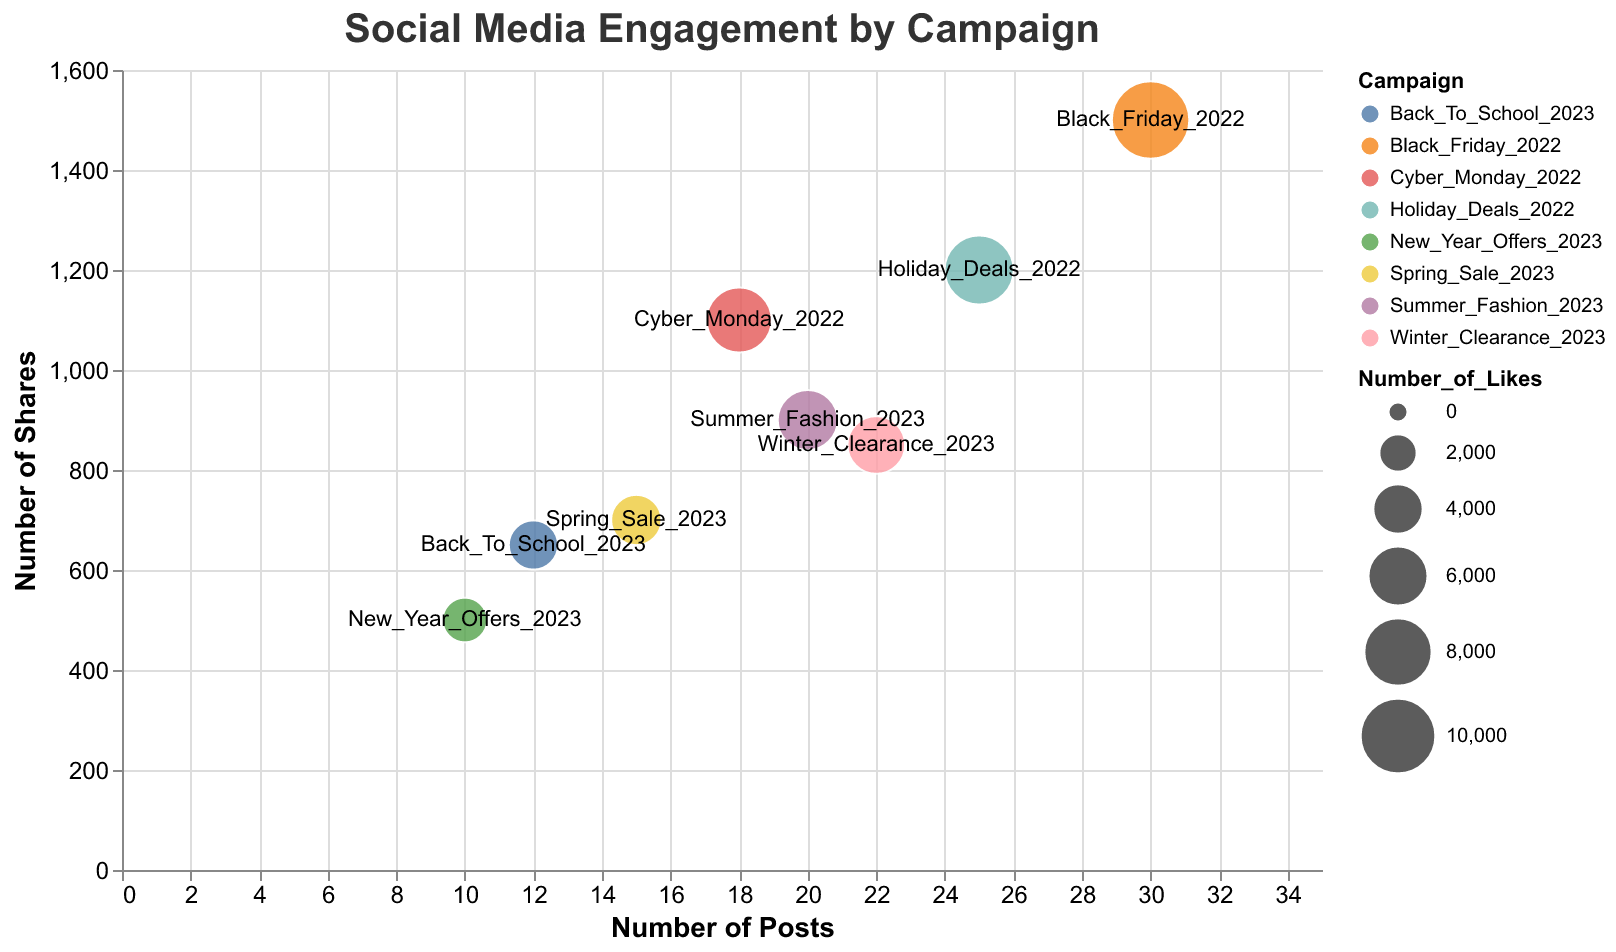What is the title of the chart? The title is displayed at the top of the figure. The text is "Social Media Engagement by Campaign".
Answer: Social Media Engagement by Campaign Which campaign had the highest number of shares? The y-axis represents the number of shares, and we look for the bubble positioned highest along this axis. "Black_Friday_2022" is positioned at the top.
Answer: Black_Friday_2022 Which campaign had the largest bubble in terms of likes? In a bubble chart, the size of the bubble represents the value of likes. The largest bubble is for the "Black_Friday_2022" campaign.
Answer: Black_Friday_2022 How many campaigns are displayed in the chart? Each bubble represents a campaign. Counting the labeled bubbles shows there are 8 campaigns in total.
Answer: 8 What is the range of the y-axis? The y-axis, representing the number of shares, has its range marked from 0 to 1600, as per the axis labels.
Answer: 0 to 1600 Which campaign has the smallest number of posts, and what is that number? The x-axis represents the number of posts. The "New_Year_Offers_2023" bubble is positioned furthest to the left, indicating it has the smallest number, which is 10 posts.
Answer: New_Year_Offers_2023, 10 Compare "Spring_Sale_2023" and "Holiday_Deals_2022". Which has more likes and shares? We compare the bubble sizes (likes) and y-positions (shares) for both campaigns. "Holiday_Deals_2022" has 8200 likes and 1200 shares, both higher than "Spring_Sale_2023" which has 4000 likes and 700 shares.
Answer: Holiday_Deals_2022 What is the cumulative number of comments for all campaigns? Summing the values from the tooltip data for each campaign's comments: 300 + 450 + 600 + 200 + 750 + 280 + 490 + 400 equals 3470 comments.
Answer: 3470 What is the average number of posts across all campaigns? Adding the number of posts from each campaign (15 + 20 + 25 + 10 + 30 + 12 + 18 + 22) gives 152. Dividing by 8 campaigns: 152 / 8 = 19 posts on average.
Answer: 19 Which campaign has approximately the same number of posts and shares? We look for a bubble where the x-value (posts) and y-value (shares) are close to each other. "Spring_Sale_2023" has 15 posts and 700 shares, which are the most similar numbers across both axes.
Answer: Spring_Sale_2023 